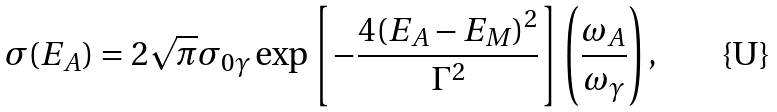Convert formula to latex. <formula><loc_0><loc_0><loc_500><loc_500>\sigma ( E _ { A } ) = 2 \sqrt { \pi } \sigma _ { 0 \gamma } \exp \left [ - \frac { 4 ( E _ { A } - E _ { M } ) ^ { 2 } } { \Gamma ^ { 2 } } \right ] \left ( \frac { \omega _ { A } } { \omega _ { \gamma } } \right ) ,</formula> 